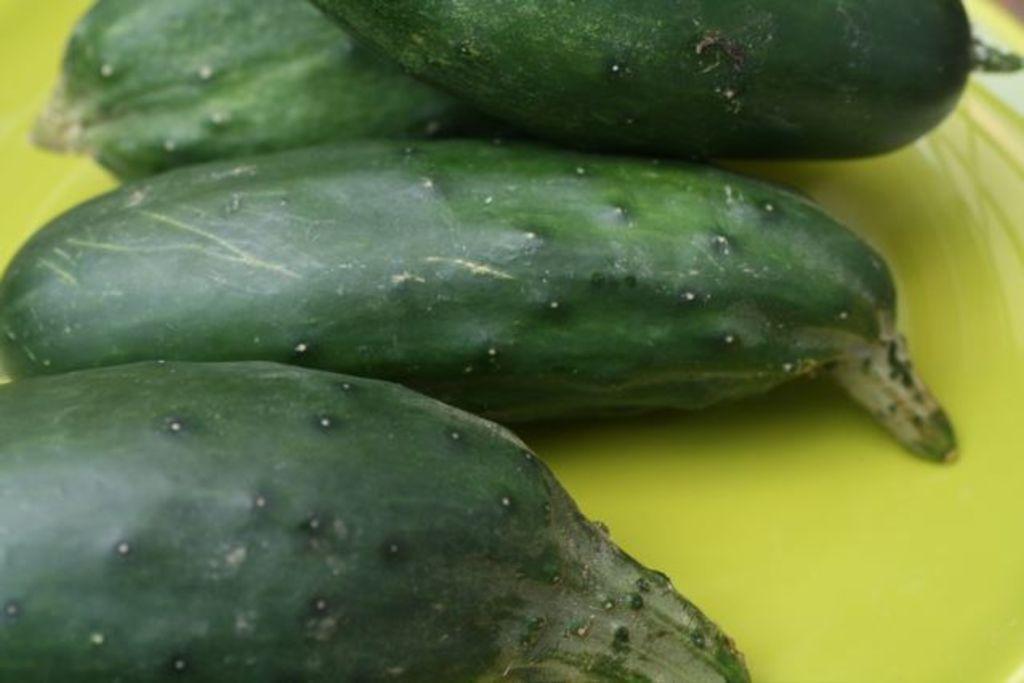Describe this image in one or two sentences. In this image I can see few vegetables. 